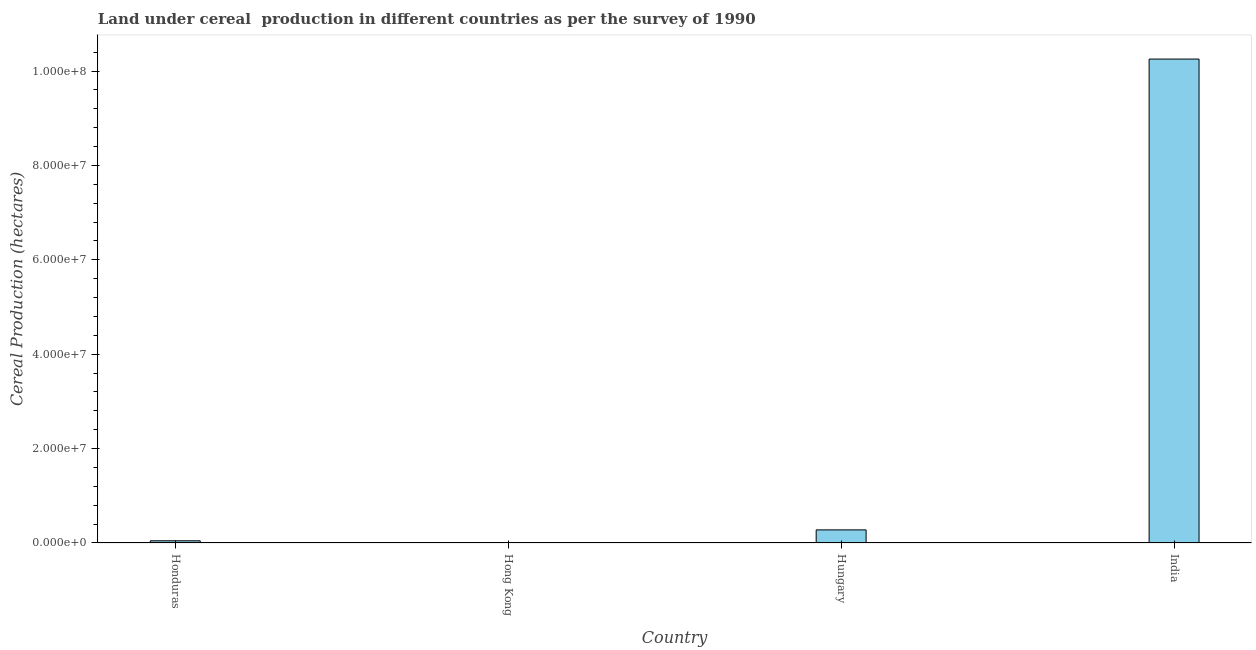What is the title of the graph?
Your response must be concise. Land under cereal  production in different countries as per the survey of 1990. What is the label or title of the X-axis?
Your answer should be very brief. Country. What is the label or title of the Y-axis?
Offer a terse response. Cereal Production (hectares). Across all countries, what is the maximum land under cereal production?
Your answer should be compact. 1.03e+08. Across all countries, what is the minimum land under cereal production?
Keep it short and to the point. 1. In which country was the land under cereal production minimum?
Offer a terse response. Hong Kong. What is the sum of the land under cereal production?
Make the answer very short. 1.06e+08. What is the difference between the land under cereal production in Hungary and India?
Offer a very short reply. -9.98e+07. What is the average land under cereal production per country?
Your answer should be compact. 2.64e+07. What is the median land under cereal production?
Give a very brief answer. 1.62e+06. What is the ratio of the land under cereal production in Honduras to that in India?
Your response must be concise. 0.01. What is the difference between the highest and the second highest land under cereal production?
Offer a terse response. 9.98e+07. Is the sum of the land under cereal production in Hong Kong and Hungary greater than the maximum land under cereal production across all countries?
Offer a terse response. No. What is the difference between the highest and the lowest land under cereal production?
Your response must be concise. 1.03e+08. How many countries are there in the graph?
Make the answer very short. 4. What is the difference between two consecutive major ticks on the Y-axis?
Your response must be concise. 2.00e+07. Are the values on the major ticks of Y-axis written in scientific E-notation?
Ensure brevity in your answer.  Yes. What is the Cereal Production (hectares) of Honduras?
Offer a terse response. 4.65e+05. What is the Cereal Production (hectares) of Hungary?
Your answer should be compact. 2.78e+06. What is the Cereal Production (hectares) of India?
Keep it short and to the point. 1.03e+08. What is the difference between the Cereal Production (hectares) in Honduras and Hong Kong?
Make the answer very short. 4.65e+05. What is the difference between the Cereal Production (hectares) in Honduras and Hungary?
Your response must be concise. -2.31e+06. What is the difference between the Cereal Production (hectares) in Honduras and India?
Your answer should be compact. -1.02e+08. What is the difference between the Cereal Production (hectares) in Hong Kong and Hungary?
Provide a succinct answer. -2.78e+06. What is the difference between the Cereal Production (hectares) in Hong Kong and India?
Provide a succinct answer. -1.03e+08. What is the difference between the Cereal Production (hectares) in Hungary and India?
Provide a short and direct response. -9.98e+07. What is the ratio of the Cereal Production (hectares) in Honduras to that in Hong Kong?
Offer a very short reply. 4.65e+05. What is the ratio of the Cereal Production (hectares) in Honduras to that in Hungary?
Provide a succinct answer. 0.17. What is the ratio of the Cereal Production (hectares) in Honduras to that in India?
Make the answer very short. 0.01. What is the ratio of the Cereal Production (hectares) in Hong Kong to that in Hungary?
Ensure brevity in your answer.  0. What is the ratio of the Cereal Production (hectares) in Hong Kong to that in India?
Offer a terse response. 0. What is the ratio of the Cereal Production (hectares) in Hungary to that in India?
Your response must be concise. 0.03. 